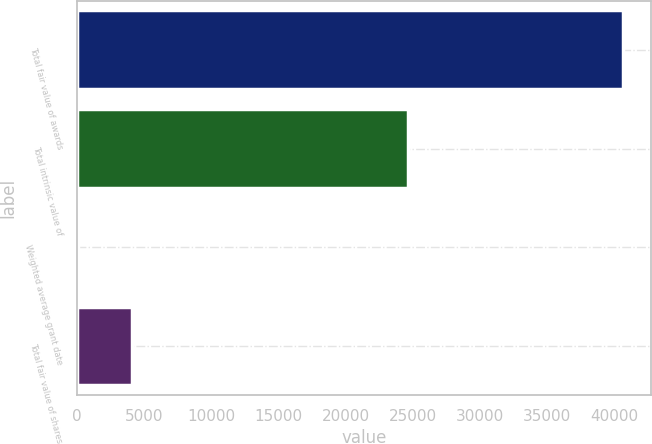Convert chart to OTSL. <chart><loc_0><loc_0><loc_500><loc_500><bar_chart><fcel>Total fair value of awards<fcel>Total intrinsic value of<fcel>Weighted average grant date<fcel>Total fair value of shares<nl><fcel>40675<fcel>24652<fcel>52.79<fcel>4115.01<nl></chart> 